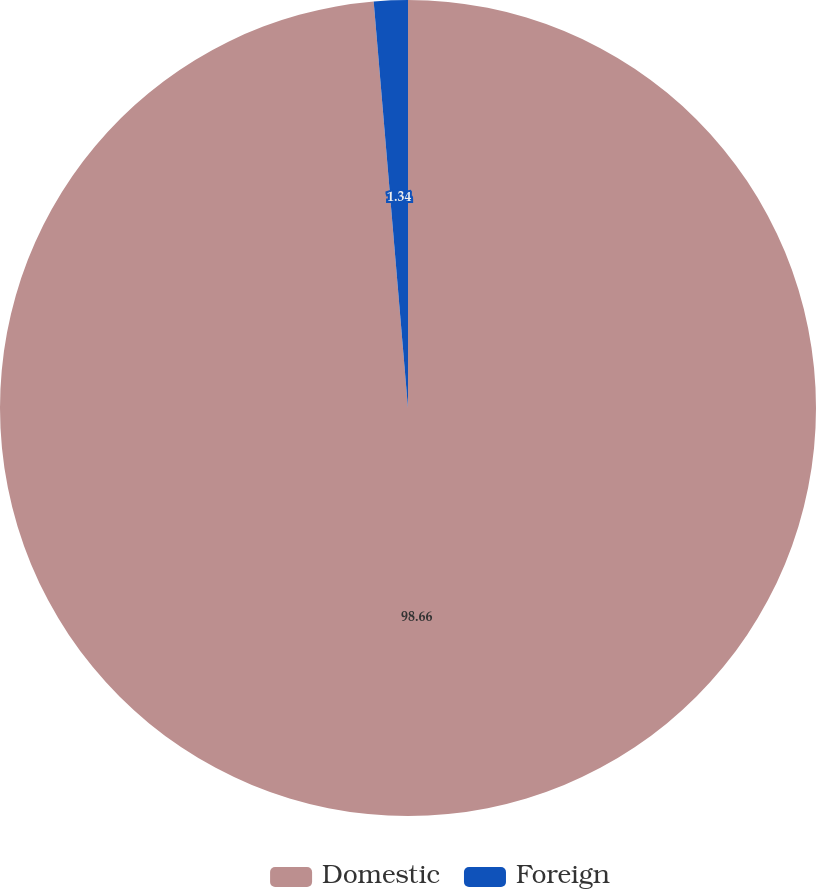Convert chart. <chart><loc_0><loc_0><loc_500><loc_500><pie_chart><fcel>Domestic<fcel>Foreign<nl><fcel>98.66%<fcel>1.34%<nl></chart> 